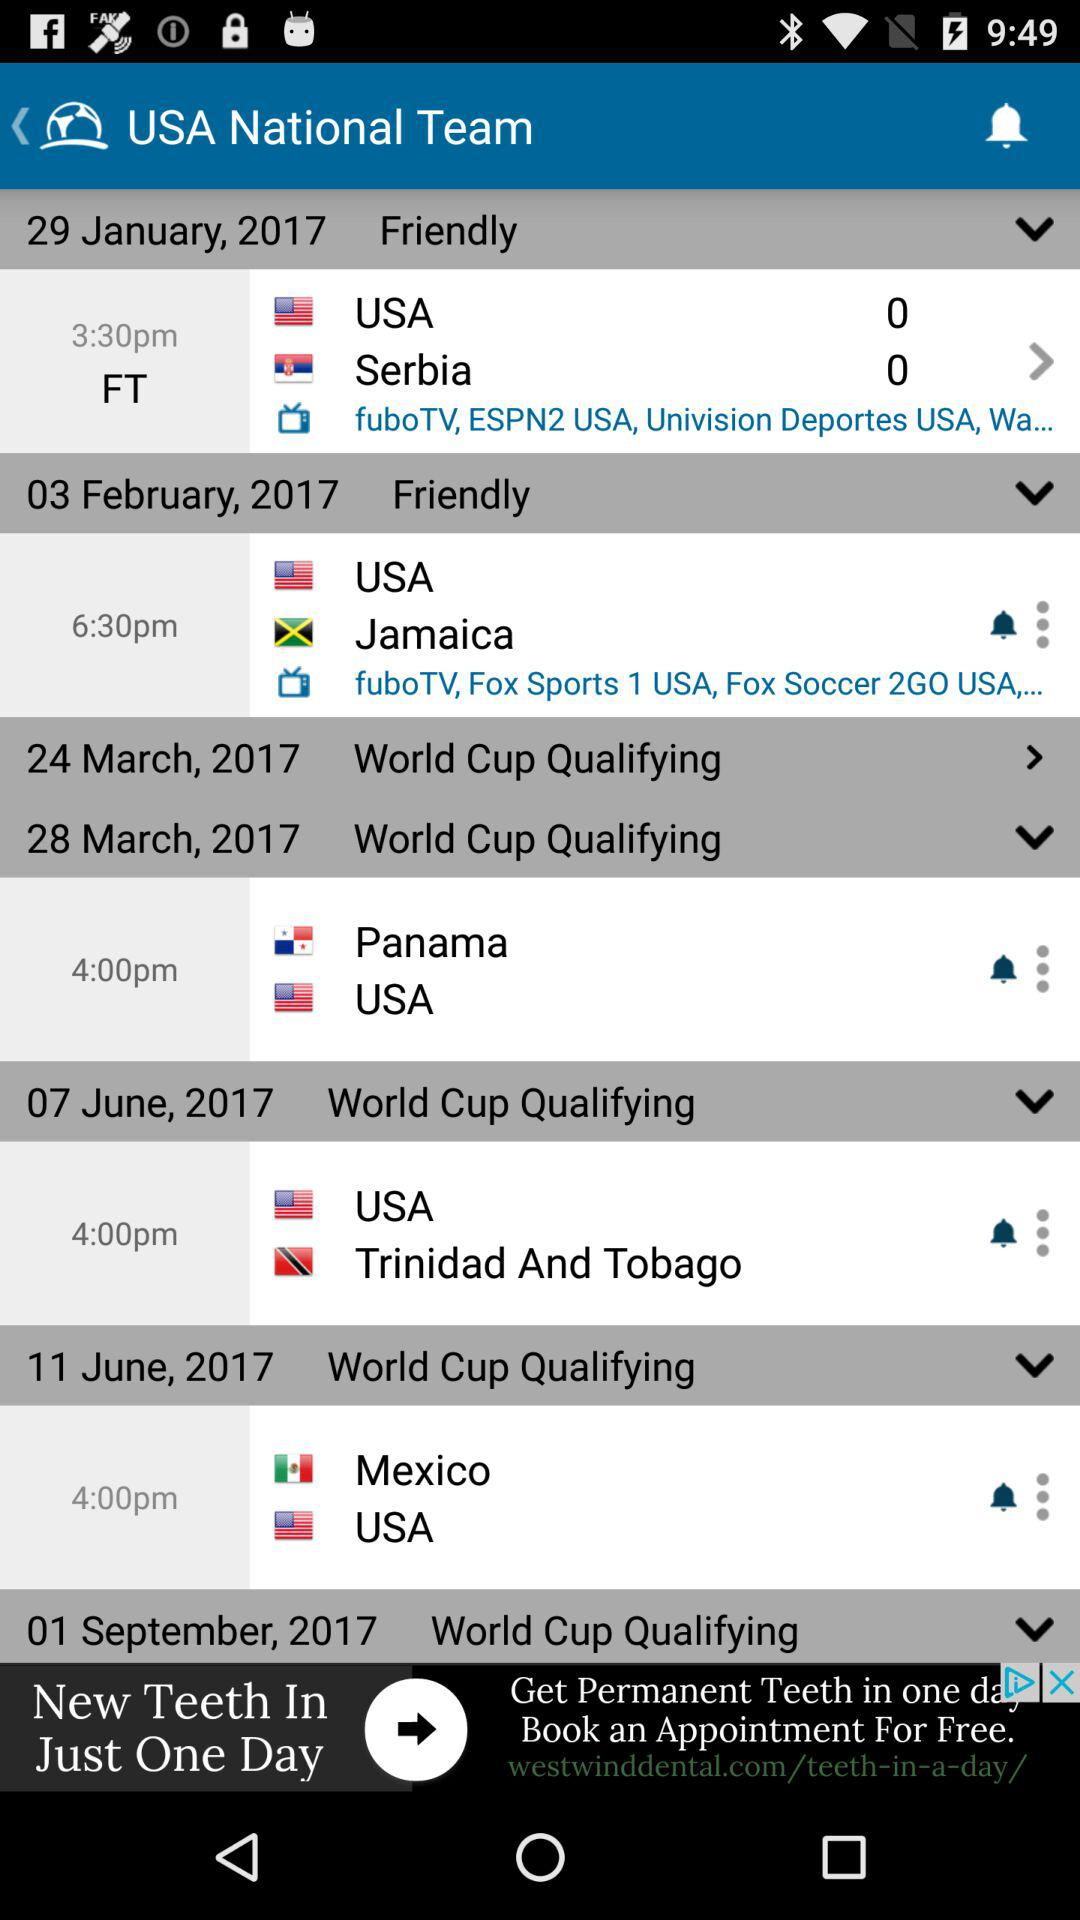Which teams are competing on June 7th, 2017? The teams that are competing on June 7th, 2017 are "USA" and "Trinidad And Tobago". 